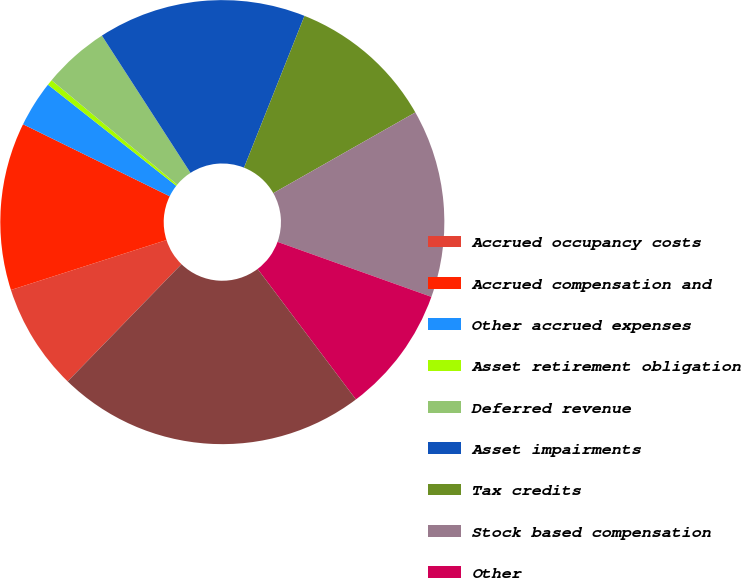<chart> <loc_0><loc_0><loc_500><loc_500><pie_chart><fcel>Accrued occupancy costs<fcel>Accrued compensation and<fcel>Other accrued expenses<fcel>Asset retirement obligation<fcel>Deferred revenue<fcel>Asset impairments<fcel>Tax credits<fcel>Stock based compensation<fcel>Other<fcel>Total<nl><fcel>7.79%<fcel>12.21%<fcel>3.36%<fcel>0.41%<fcel>4.84%<fcel>15.16%<fcel>10.74%<fcel>13.69%<fcel>9.26%<fcel>22.54%<nl></chart> 